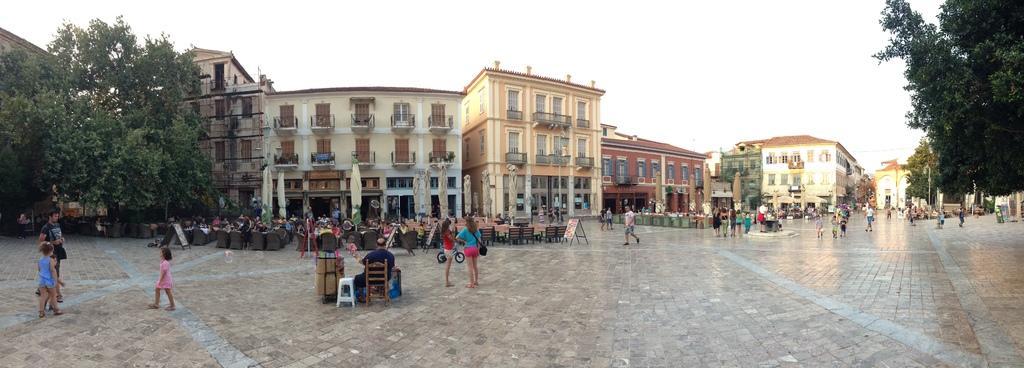Describe this image in one or two sentences. In this picture we can see chairs, wooden objects, bicycle and few other things on the path. There are few people sitting on the chair. We can see few buildings, street lights and poles in the background. Three people are visible on the left side. 